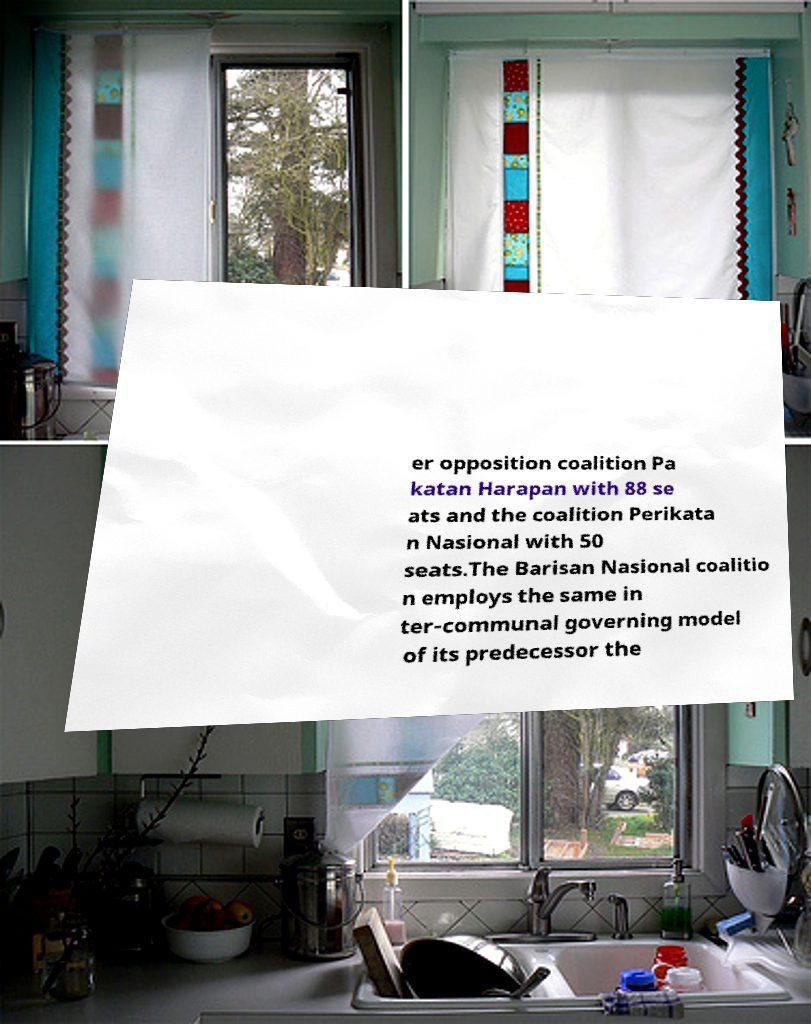Can you read and provide the text displayed in the image?This photo seems to have some interesting text. Can you extract and type it out for me? er opposition coalition Pa katan Harapan with 88 se ats and the coalition Perikata n Nasional with 50 seats.The Barisan Nasional coalitio n employs the same in ter-communal governing model of its predecessor the 